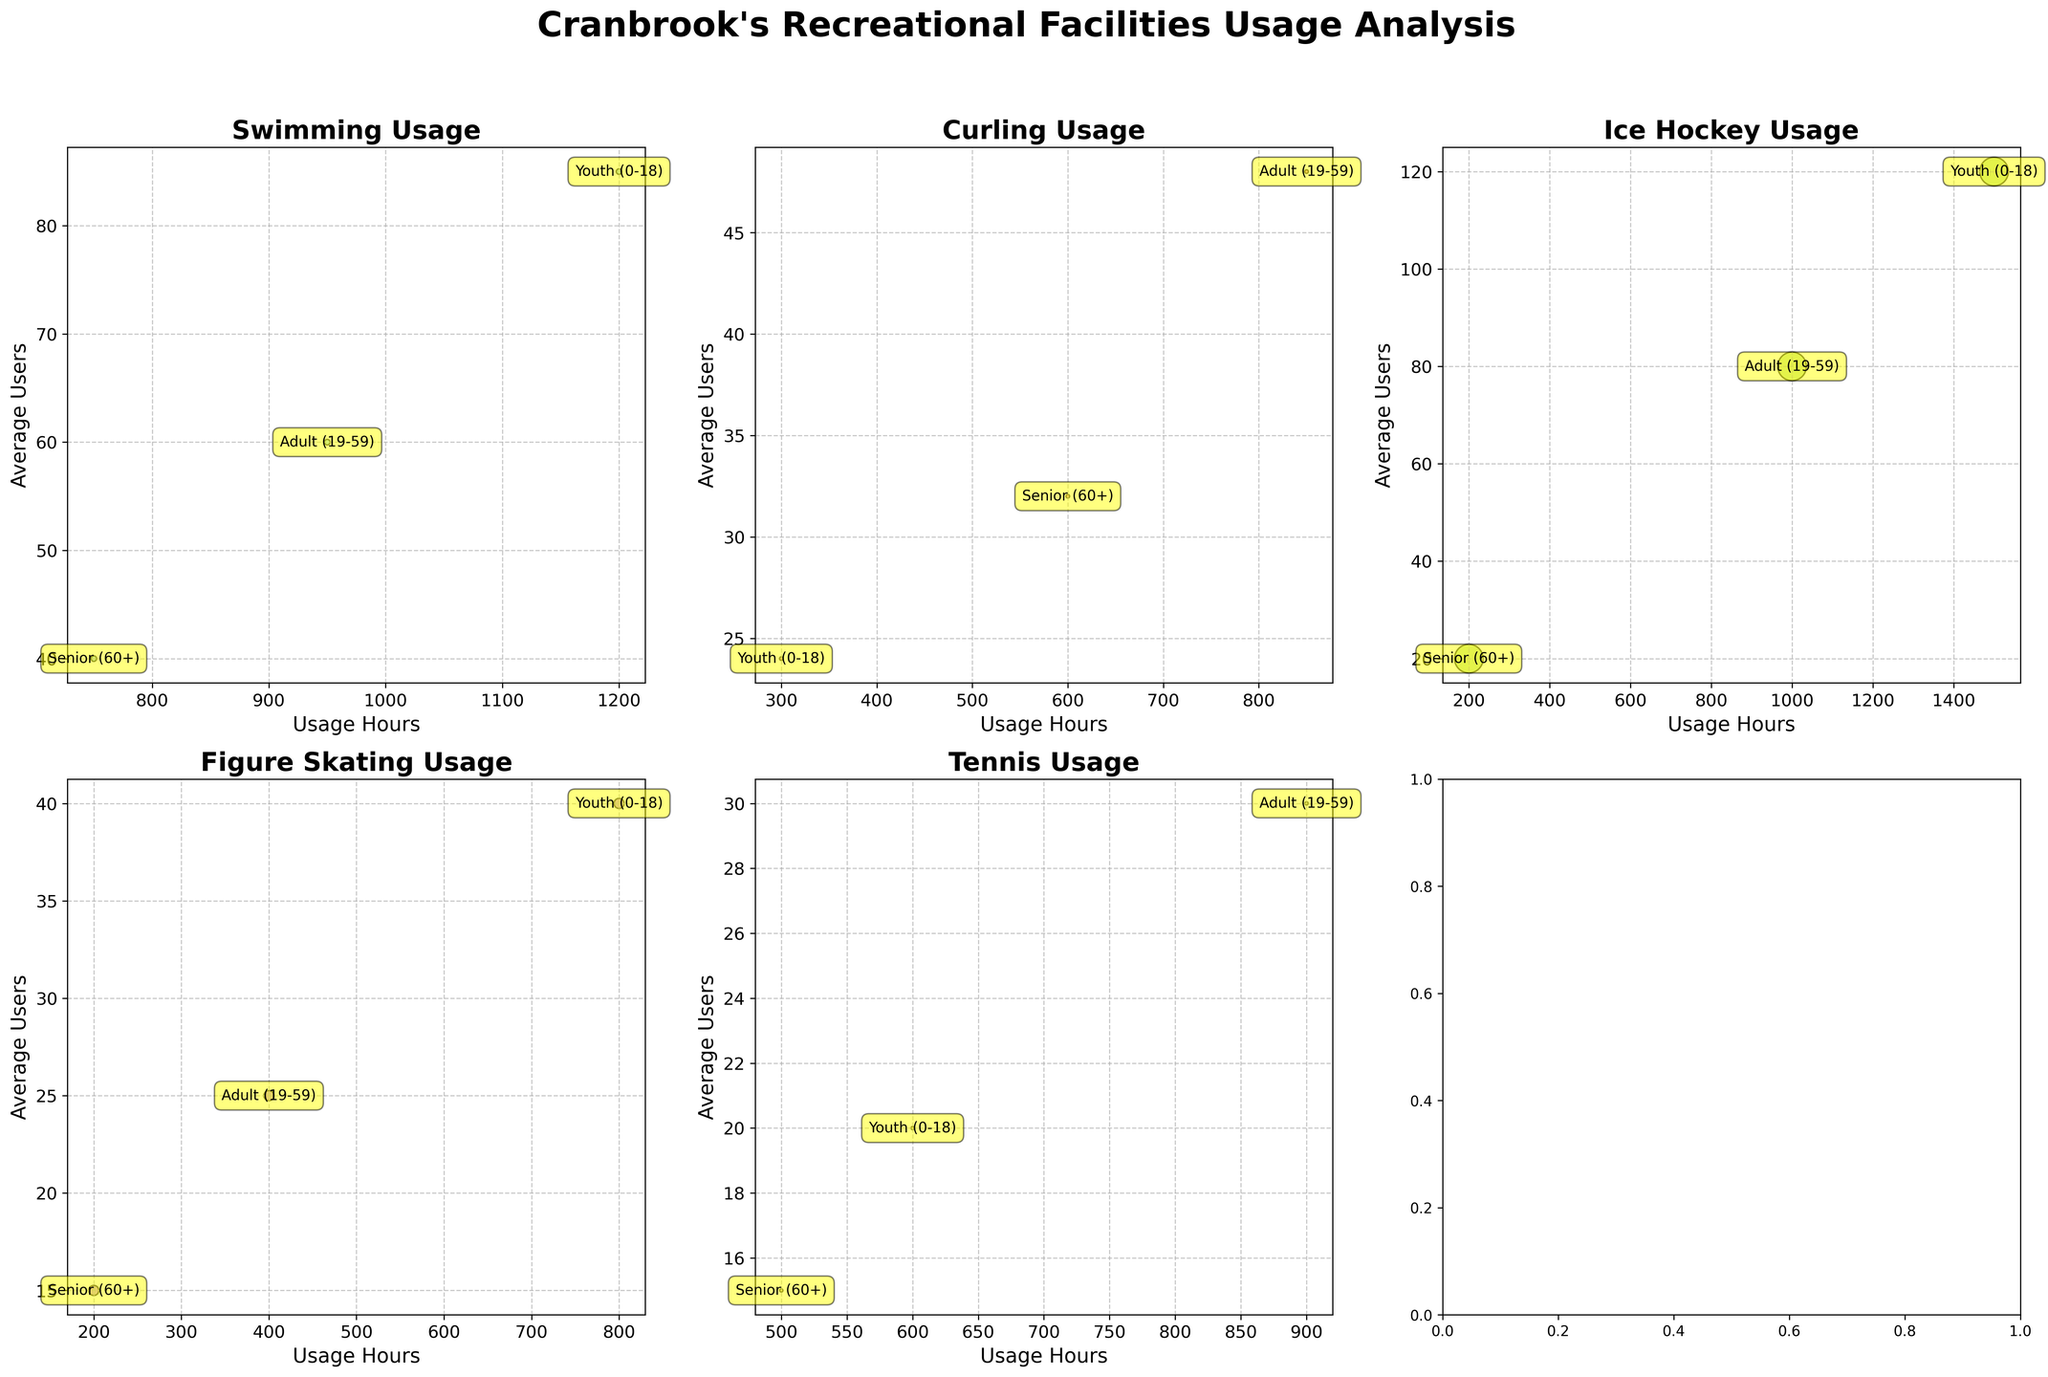What is the title of the entire figure? The title is usually located at the top center of the figure. It is written in a large and bold font indicating the main focus of the chart.
Answer: Cranbrook's Recreational Facilities Usage Analysis Which sport has the highest capacity bubble? Check the bubbles with maximum size across all subplots. The larger the bubble, the greater the capacity. The bubble for Ice Hockey stands out as the largest.
Answer: Ice Hockey Compare the average users of Youth and Adult groups for Swimming. Which group has more average users? In the Swimming section, we compare the positions of the bubbles labeled 'Youth (0-18)' and 'Adult (19-59)' on the y-axis representing 'Average Users'.
Answer: Youth (0-18) Which facility has the lowest usage for Senior (60+) group? Look for the bubble labeled 'Senior (60+)' with the lowest x-axis value. The one for Ice Hockey at Western Financial Place is the lowest.
Answer: Western Financial Place What age group uses Figure Skating the most in terms of hours? In the Figure Skating subplot at the Kinsmen Arena, compare the x-axis positions of bubbles. The bubble labeled 'Youth (0-18)' is furthest to the right.
Answer: Youth (0-18) Using Ice Hockey as an example, compare the disparity between the usage hours of the Youth group and Senior group. How much more does the Youth group use it? For Ice Hockey, find the difference in x-axis values (Usage Hours) between 'Youth (0-18)' and 'Senior (60+)'. The values are 1500 and 200, respectively. The difference is 1500 - 200.
Answer: 1300 hours Which sport demonstrates the smallest bubble size? Bubble size corresponds to facility capacity. The smallest bubbles will indicate the lowest capacity. Tennis at Cranbrook Tennis Club shows the smallest bubbles.
Answer: Tennis Compare the average users for Seniors (60+) between Curling and Tennis. Which sport has more users on average? In both Curling and Tennis subplots, compare the y-axis values of bubbles labeled 'Senior (60+).' Curling has a higher position.
Answer: Curling Which sport shows a comparatively balanced distribution across all age groups in terms of average users? Examine all subplots for sports where bubbles for each age group have similar y-axis values. Swimming at Cranbrook Aquatic Centre shows a more balanced distribution.
Answer: Swimming How does the facility capacity affect the size of the bubbles in these plots? Bubbles represent the capacity divided by 10, meaning larger capacity results in larger bubbles visually across subplots.
Answer: Larger capacity results in larger bubbles 